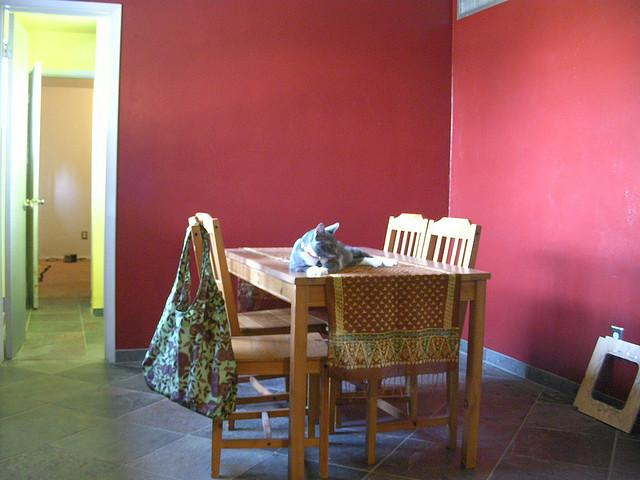What is the cat on top of?

Choices:
A) basket
B) cardboard box
C) table
D) human tummy table 